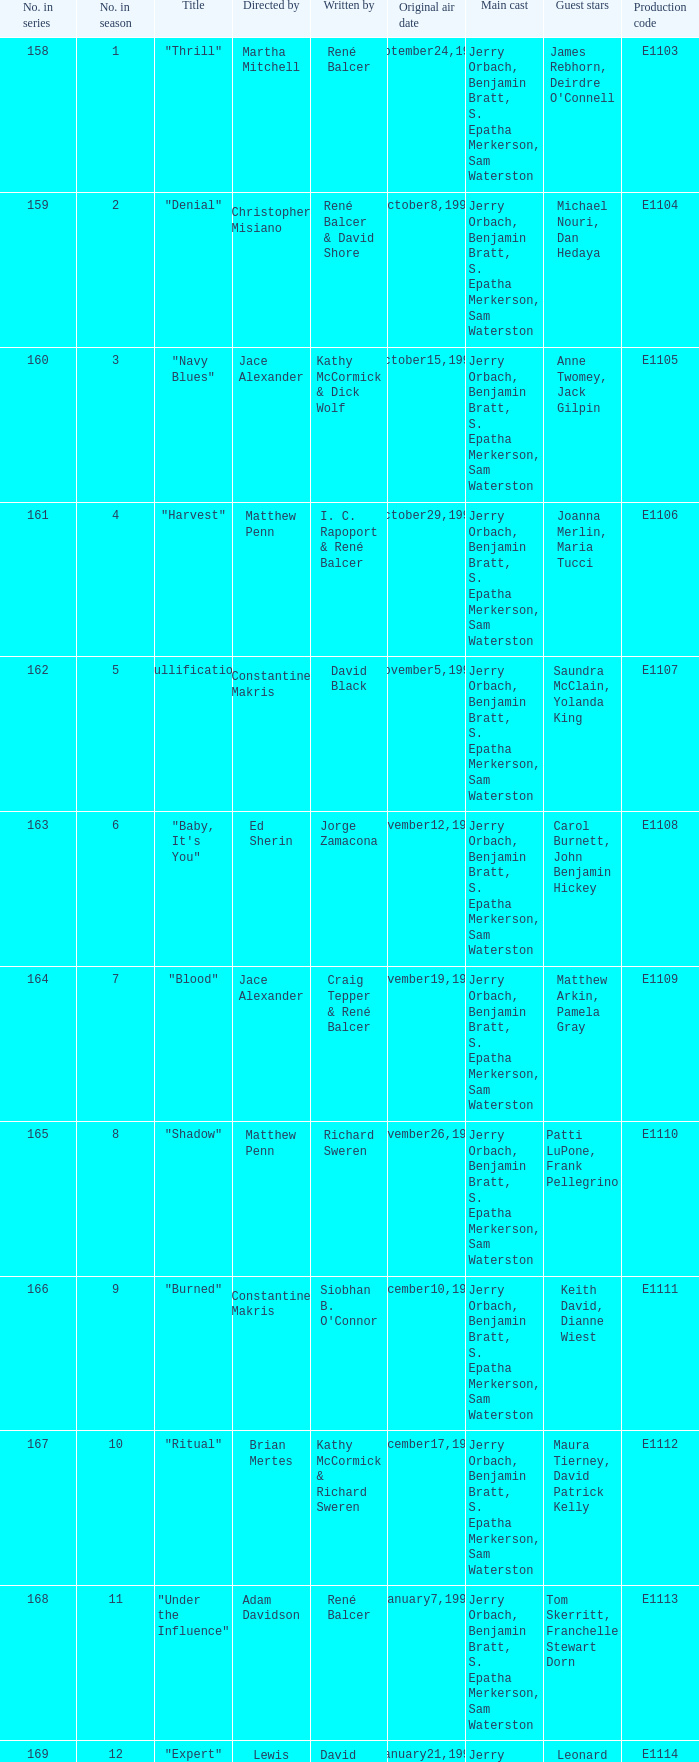The first episode in this season had what number in the series?  158.0. 